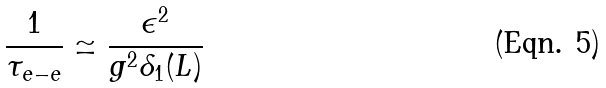Convert formula to latex. <formula><loc_0><loc_0><loc_500><loc_500>\frac { 1 } { \tau _ { e - e } } \simeq \frac { \epsilon ^ { 2 } } { g ^ { 2 } \delta _ { 1 } ( L ) }</formula> 